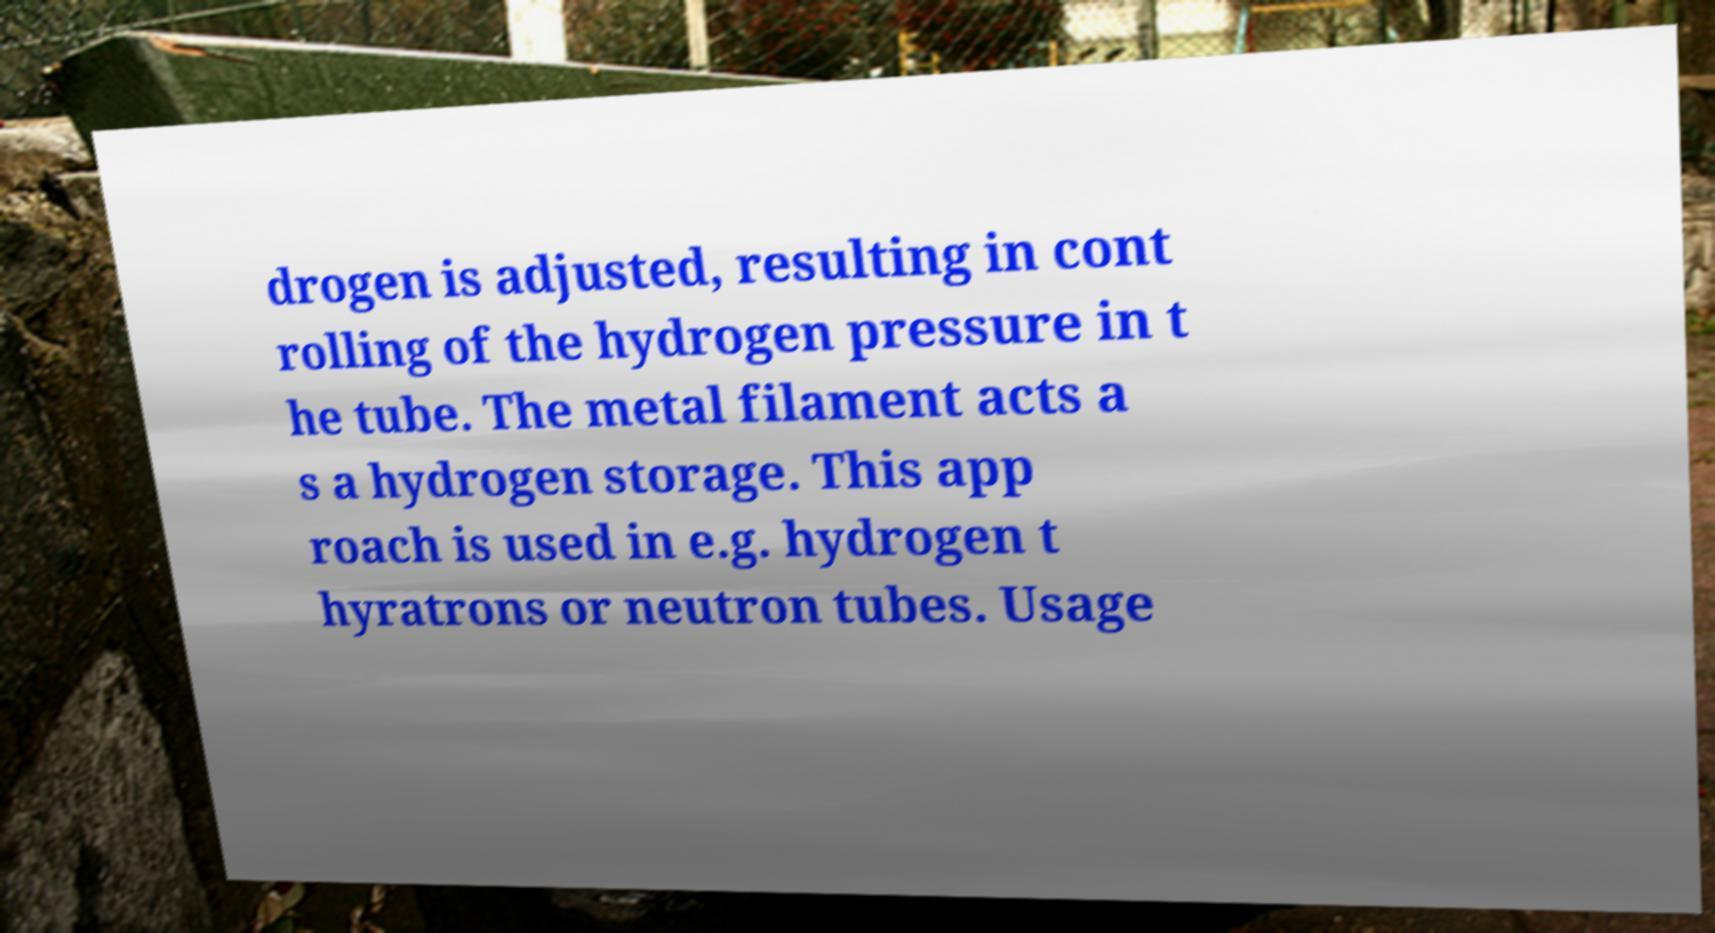Can you read and provide the text displayed in the image?This photo seems to have some interesting text. Can you extract and type it out for me? drogen is adjusted, resulting in cont rolling of the hydrogen pressure in t he tube. The metal filament acts a s a hydrogen storage. This app roach is used in e.g. hydrogen t hyratrons or neutron tubes. Usage 